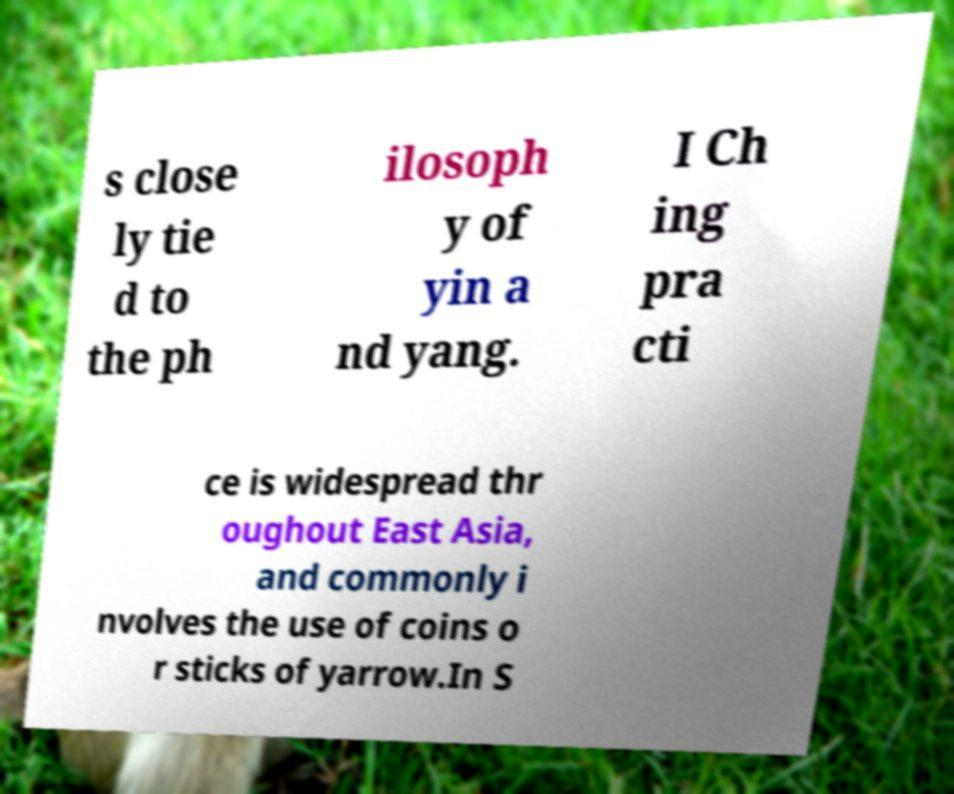There's text embedded in this image that I need extracted. Can you transcribe it verbatim? s close ly tie d to the ph ilosoph y of yin a nd yang. I Ch ing pra cti ce is widespread thr oughout East Asia, and commonly i nvolves the use of coins o r sticks of yarrow.In S 